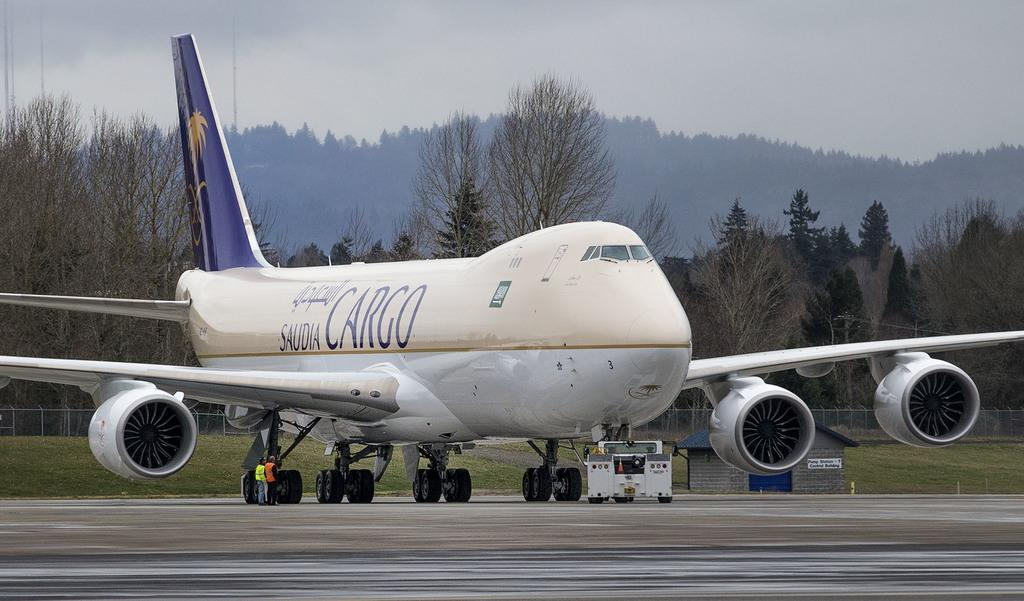<image>
Create a compact narrative representing the image presented. the word cargo is on the white plane 